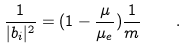Convert formula to latex. <formula><loc_0><loc_0><loc_500><loc_500>\frac { 1 } { | b _ { i } | ^ { 2 } } = ( 1 - \frac { \mu } { \mu _ { e } } ) \frac { 1 } { m } \quad .</formula> 